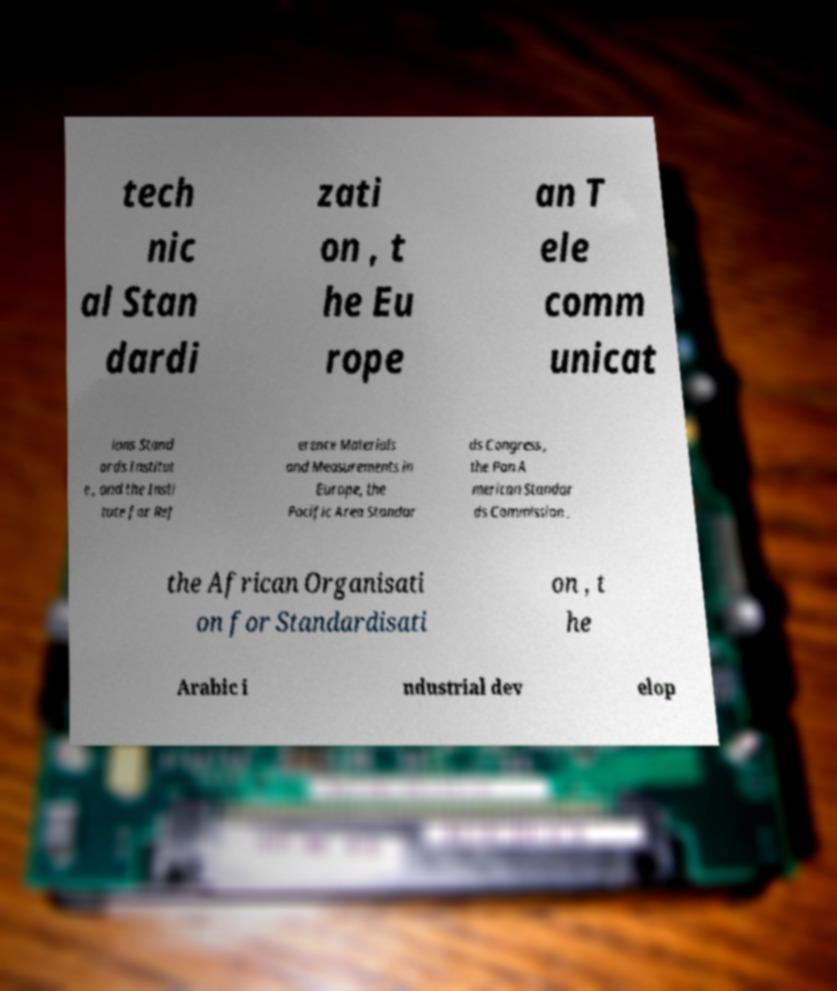Could you extract and type out the text from this image? tech nic al Stan dardi zati on , t he Eu rope an T ele comm unicat ions Stand ards Institut e , and the Insti tute for Ref erence Materials and Measurements in Europe, the Pacific Area Standar ds Congress , the Pan A merican Standar ds Commission , the African Organisati on for Standardisati on , t he Arabic i ndustrial dev elop 